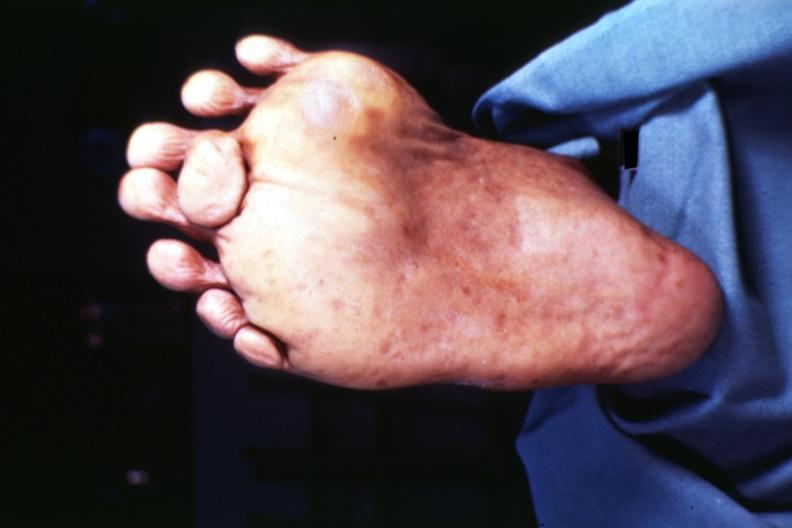s arachnodactyly present?
Answer the question using a single word or phrase. No 